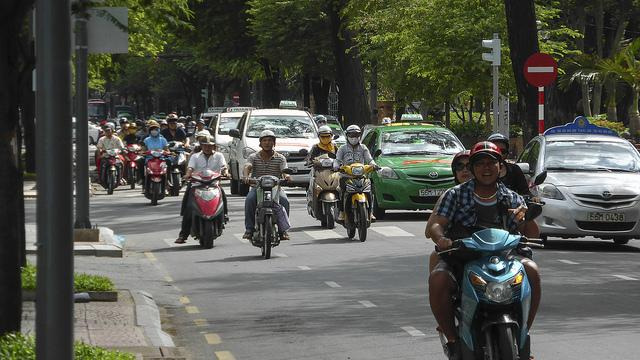How many directions does traffic flow in these pictured lanes? Please explain your reasoning. one. The traffic is all going the same way. 